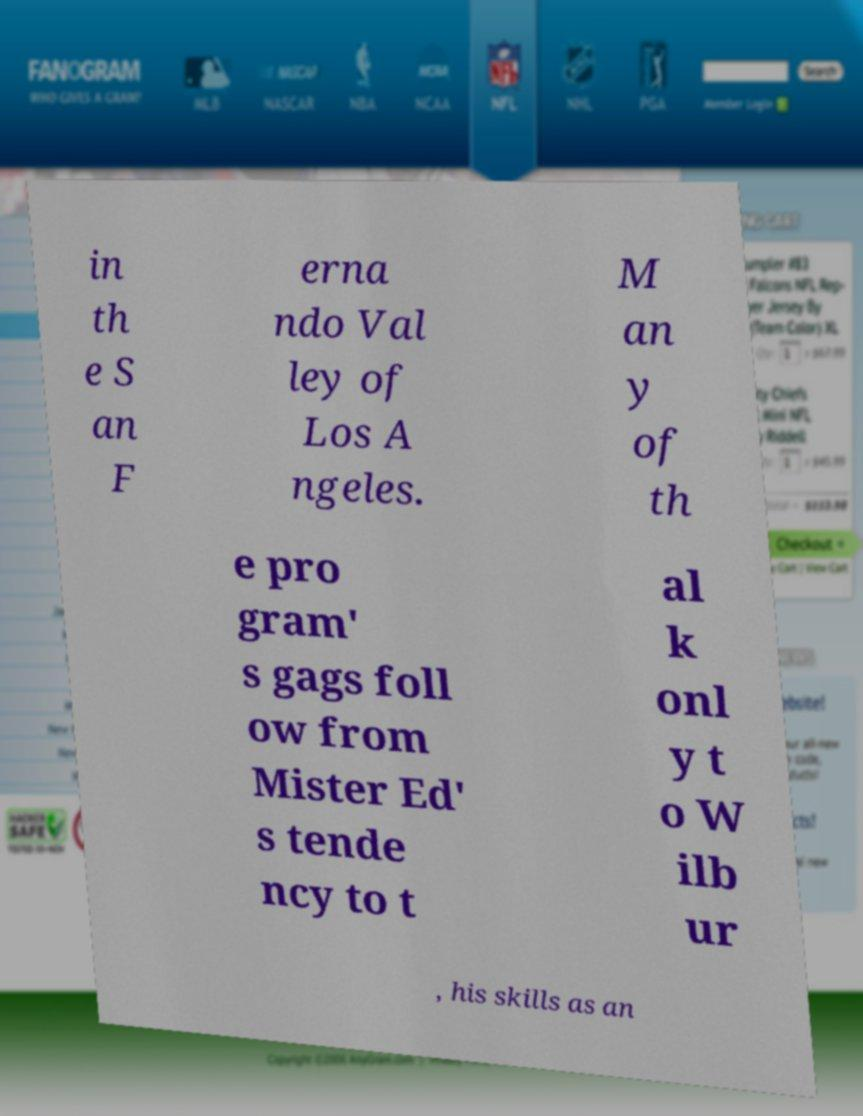What messages or text are displayed in this image? I need them in a readable, typed format. in th e S an F erna ndo Val ley of Los A ngeles. M an y of th e pro gram' s gags foll ow from Mister Ed' s tende ncy to t al k onl y t o W ilb ur , his skills as an 